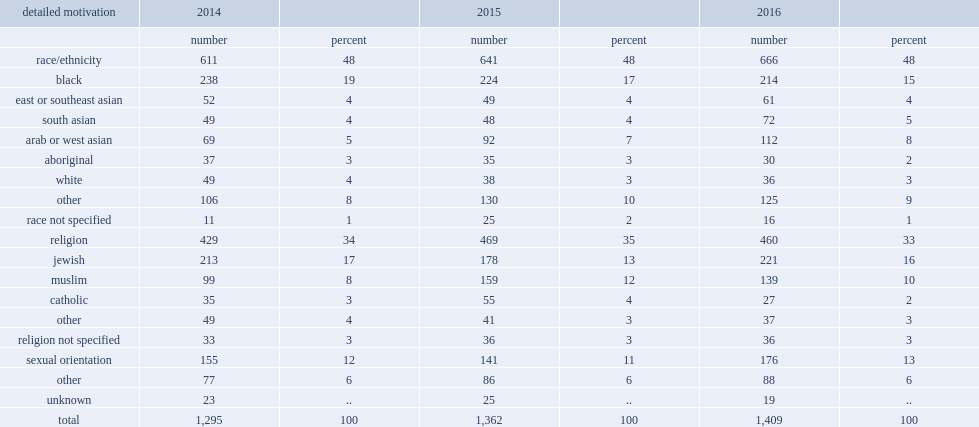What percentage of hate crimes targeting a race or ethnicity did hate crimes targeting arabs and west asians account for in 2016? 8.0. 